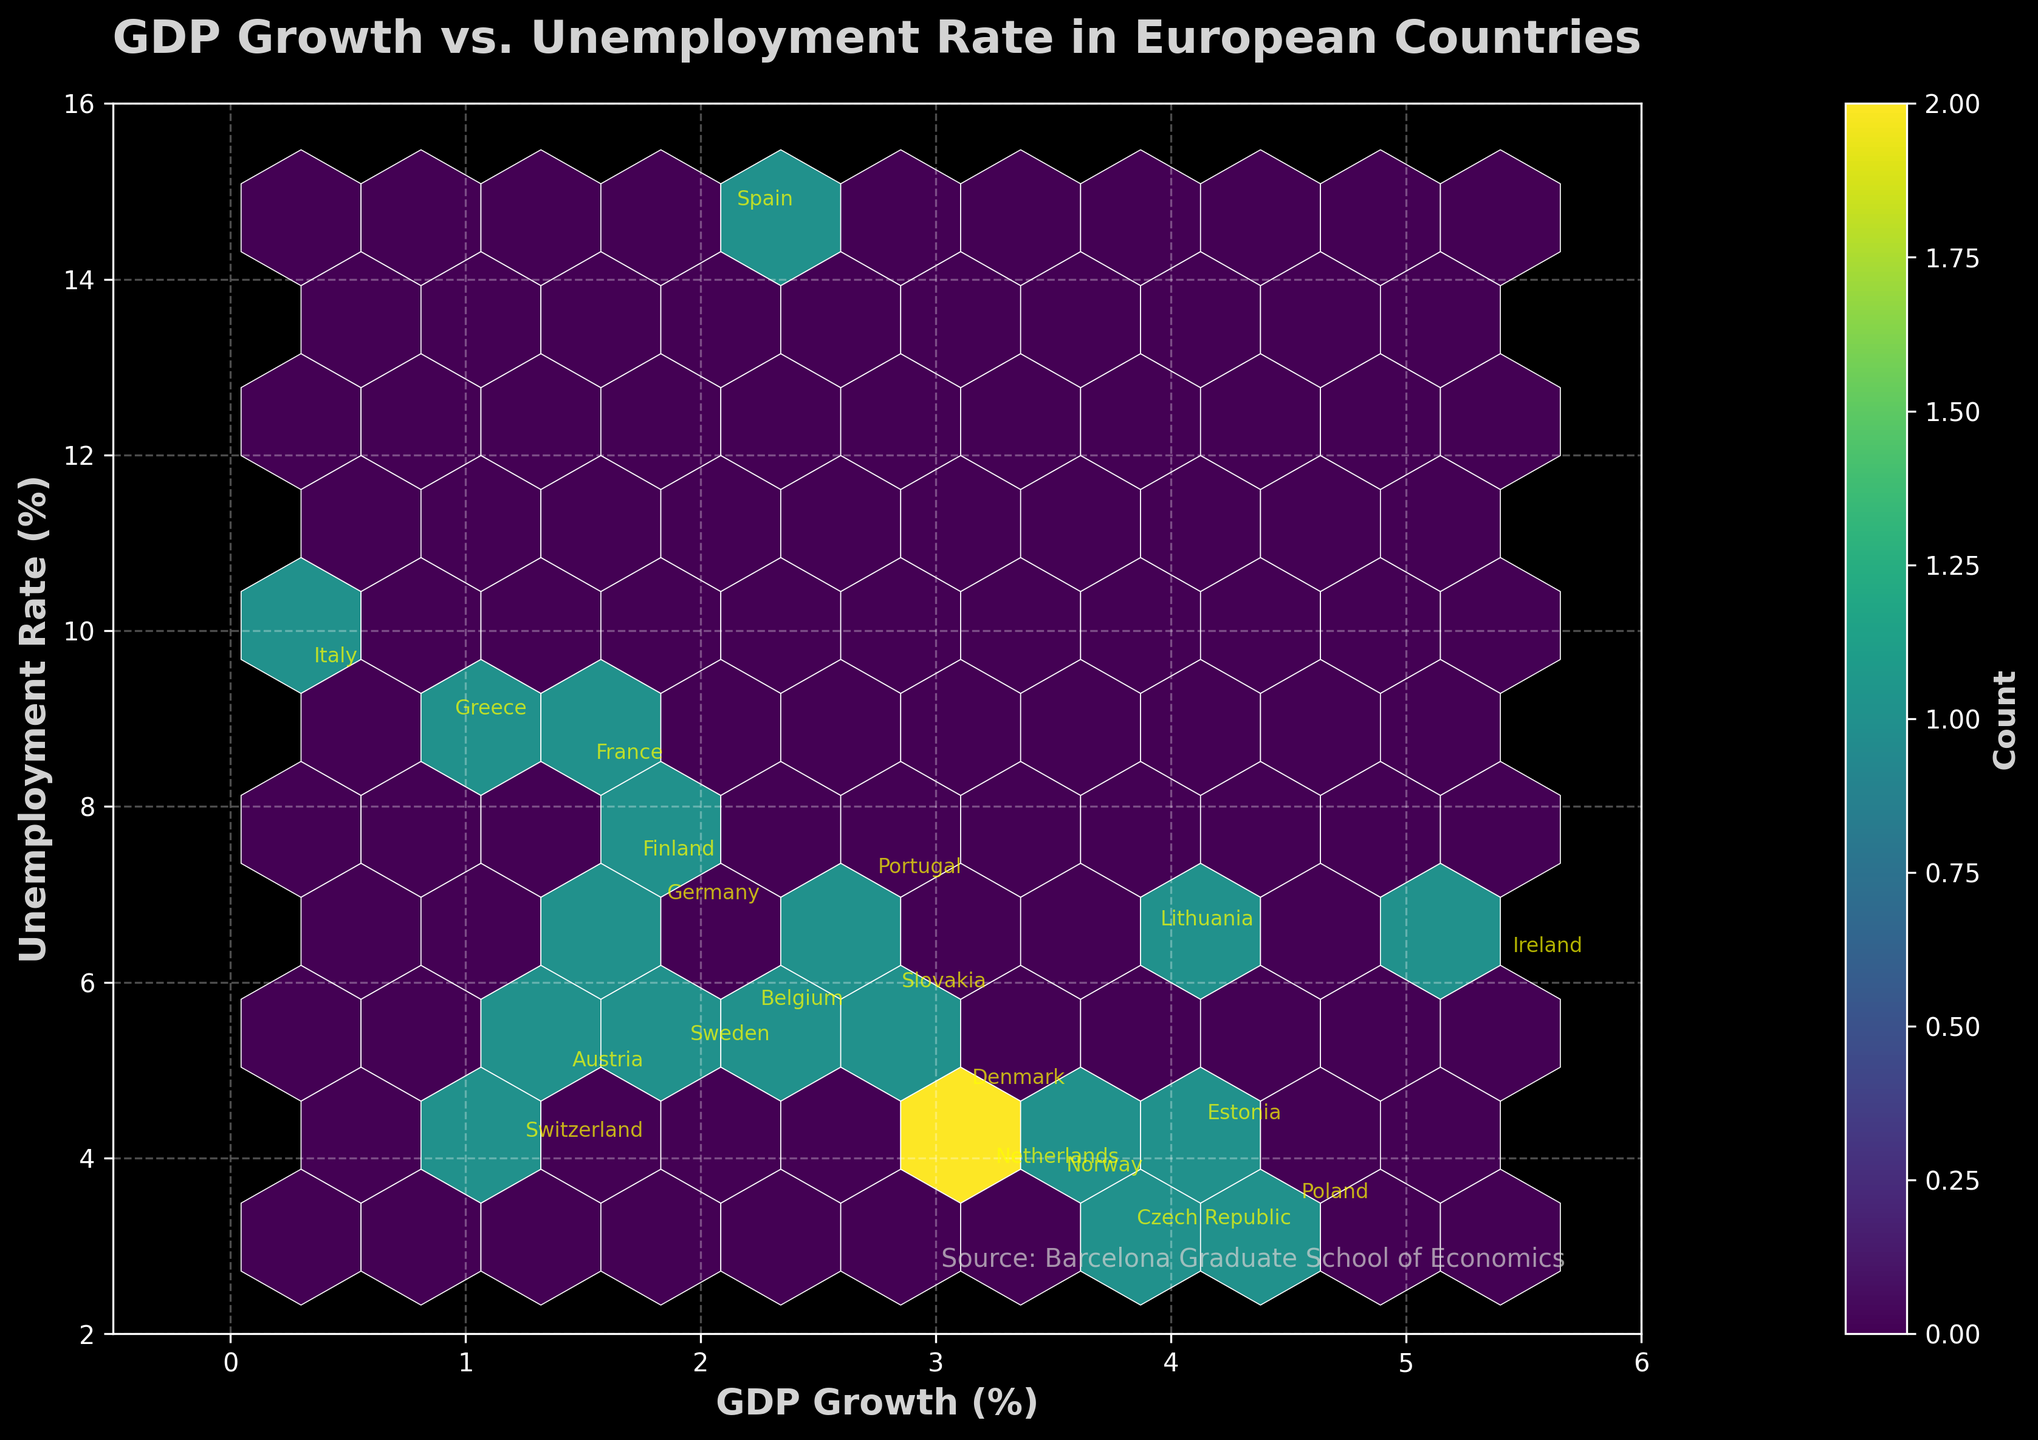What is the title of the figure? The title of the figure is located at the top center of the plot and provides an overview of what the plot is displaying. In this case, it reads "GDP Growth vs. Unemployment Rate in European Countries", which indicates the variables being plotted and the scope of the data.
Answer: GDP Growth vs. Unemployment Rate in European Countries How many data points are plotted in the hexbin plot? The number of data points can be determined by counting the individual entries listed in the data. There are 19 pairs of GDP growth and unemployment rate data points representing 19 European countries plotted in the hexbin plot.
Answer: 19 Which country has the highest GDP growth rate? By observing the annotations on the hexbin plot, we can see that the highest GDP growth rate is 5.4%, which corresponds to Ireland, indicated by the annotation near the point at (5.4, 6.2).
Answer: Ireland What are the axis labels for the hexbin plot? The axis labels describe the variables plotted on each axis. The x-axis label is "GDP Growth (%)" and the y-axis label is "Unemployment Rate (%)". These labels are shown in bold light-gray text.
Answer: GDP Growth (%) and Unemployment Rate (%) What is the color scheme used in the hexbin plot, and what does it represent? The color scheme is a gradient of colors from the 'viridis' colormap, transitioning from dark to light colors. This gradient represents the count of data points within each hexbin; lighter hexagons indicate higher counts.
Answer: Viridis colormap; lighter colors indicate more data points Which country has the lowest unemployment rate, and what is its GDP growth rate? By looking at the annotations, the country with the lowest unemployment rate is the Czech Republic, with a 3.1% unemployment rate, and its GDP growth rate is 3.8%.
Answer: Czech Republic, 3.8% How is the colorbar labeled, and what does it indicate on the plot? The colorbar is labeled "Count" and is located to the right of the plot. It indicates the number of data points within each hexagonal bin on the plot, with darker colors representing fewer data points and lighter colors representing more.
Answer: Count; number of data points in each hexbin What is the general relationship between GDP growth and unemployment rates observed in the plot? The figure shows a trend where countries with higher GDP growth rates tend to have lower unemployment rates, and those with lower GDP growth tend to have higher unemployment rates. This is visible by noting the general downward slope from left to right in the data distribution.
Answer: Higher GDP growth generally correlates with lower unemployment rates 